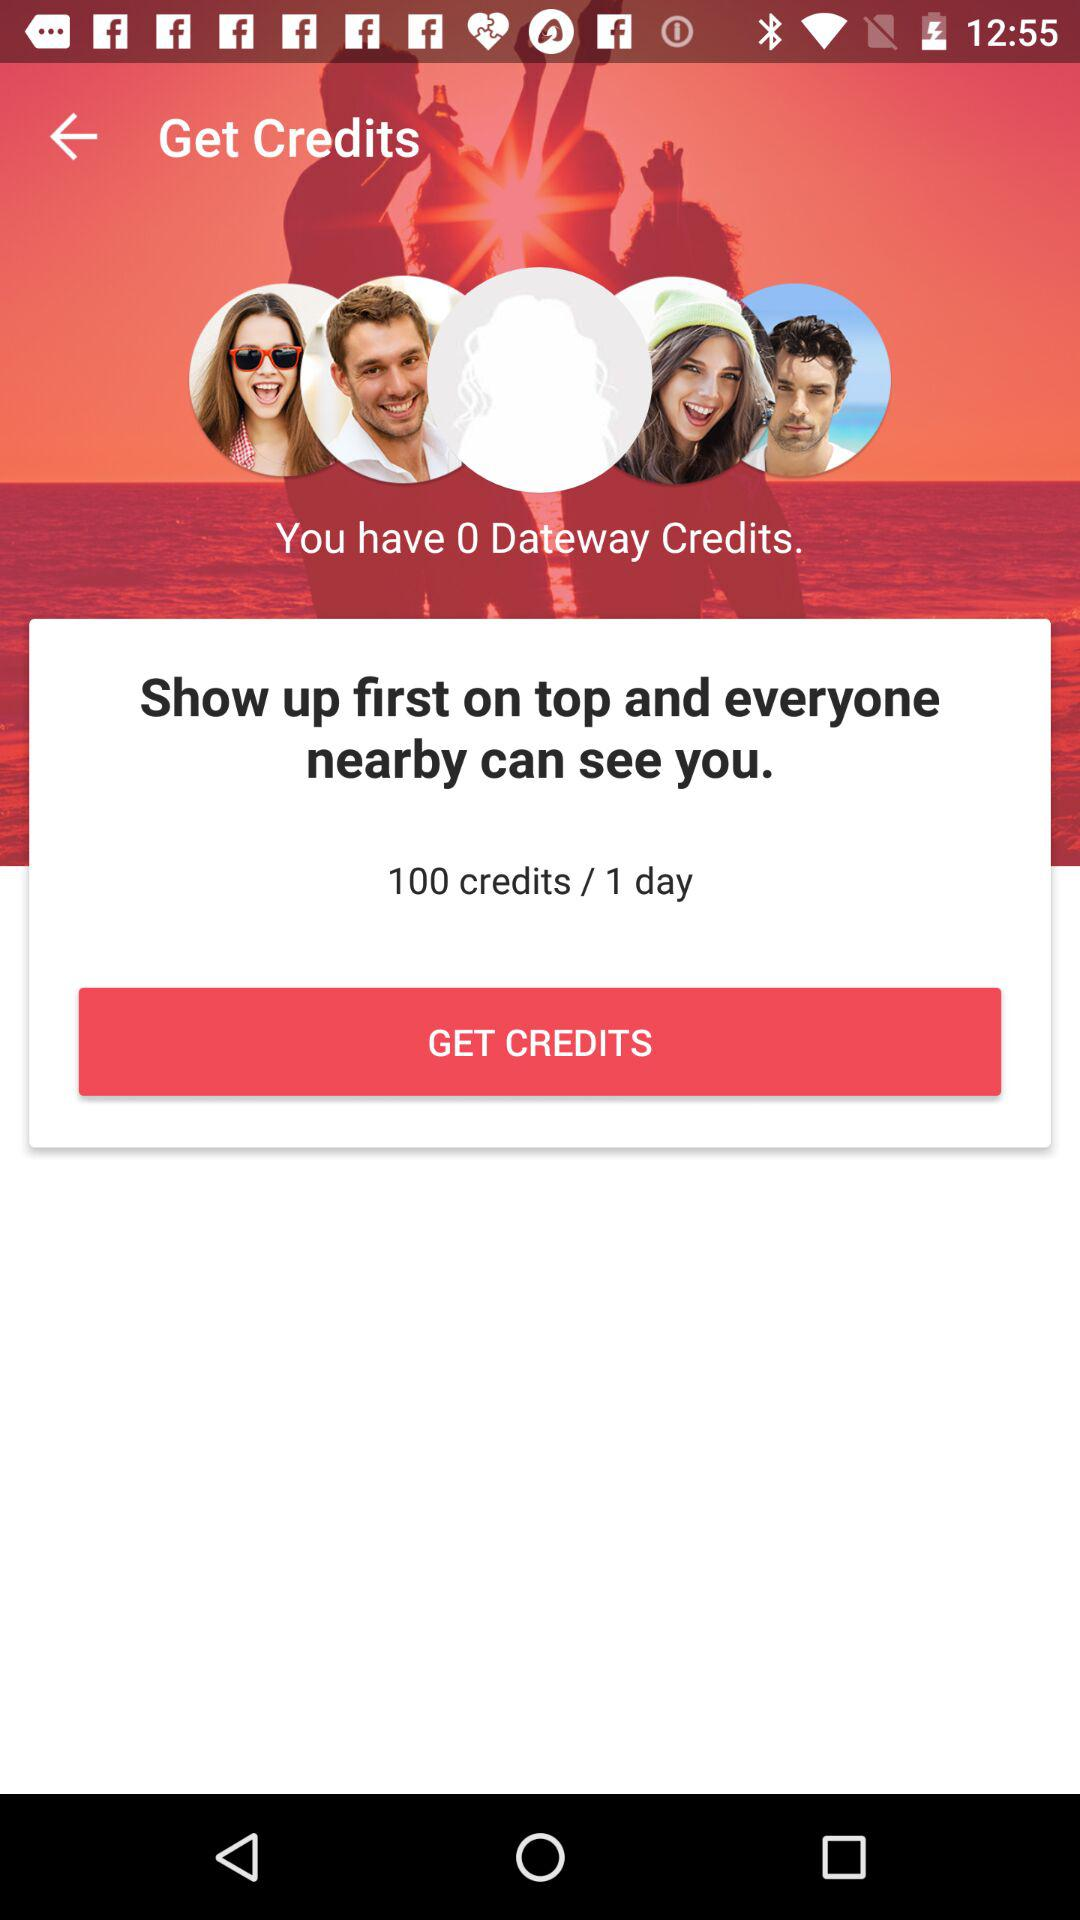How many credits do I need to buy to show up first on top?
Answer the question using a single word or phrase. 100 